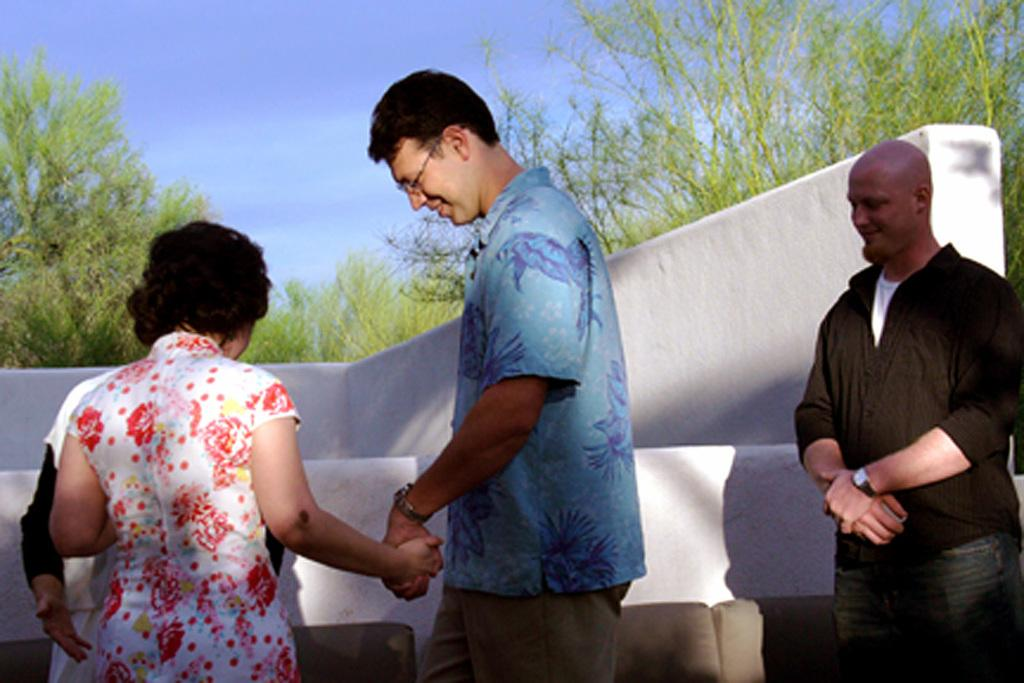How many people are in the image? There are two people in the image. What are the two people doing in the image? The two people in the middle are holding hands. What can be seen in the background of the image? There are trees visible in the background of the image. What type of cork can be seen in the image? There is no cork present in the image. What health benefits are associated with the activity depicted in the image? The image does not provide enough information to determine any health benefits associated with the activity. 